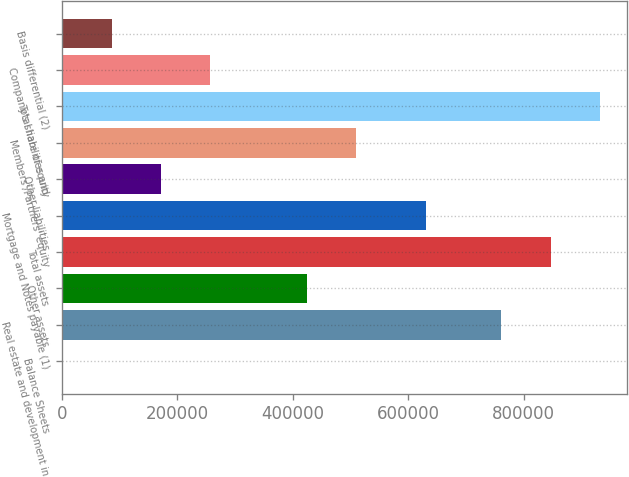Convert chart. <chart><loc_0><loc_0><loc_500><loc_500><bar_chart><fcel>Balance Sheets<fcel>Real estate and development in<fcel>Other assets<fcel>Total assets<fcel>Mortgage and Notes payable (1)<fcel>Other liabilities<fcel>Members'/Partners' equity<fcel>Total liabilities and<fcel>Company's share of equity<fcel>Basis differential (2)<nl><fcel>2006<fcel>760139<fcel>424952<fcel>847898<fcel>630254<fcel>171184<fcel>509541<fcel>932487<fcel>255774<fcel>86595.2<nl></chart> 